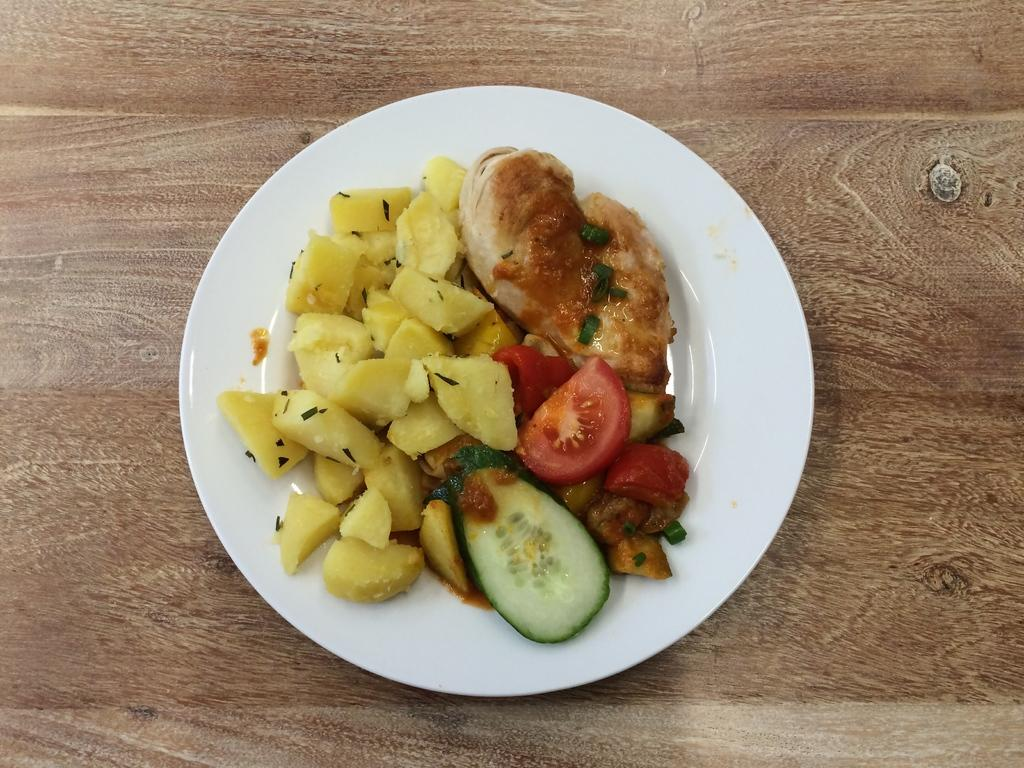What is on the plate that is visible in the image? There is a plate with food in the image. What type of surface does the plate appear to be resting on? The wooden surface in the image looks like a table. Where is the glue being used in the image? There is no glue present in the image. What type of gate can be seen in the image? There is no gate present in the image. 